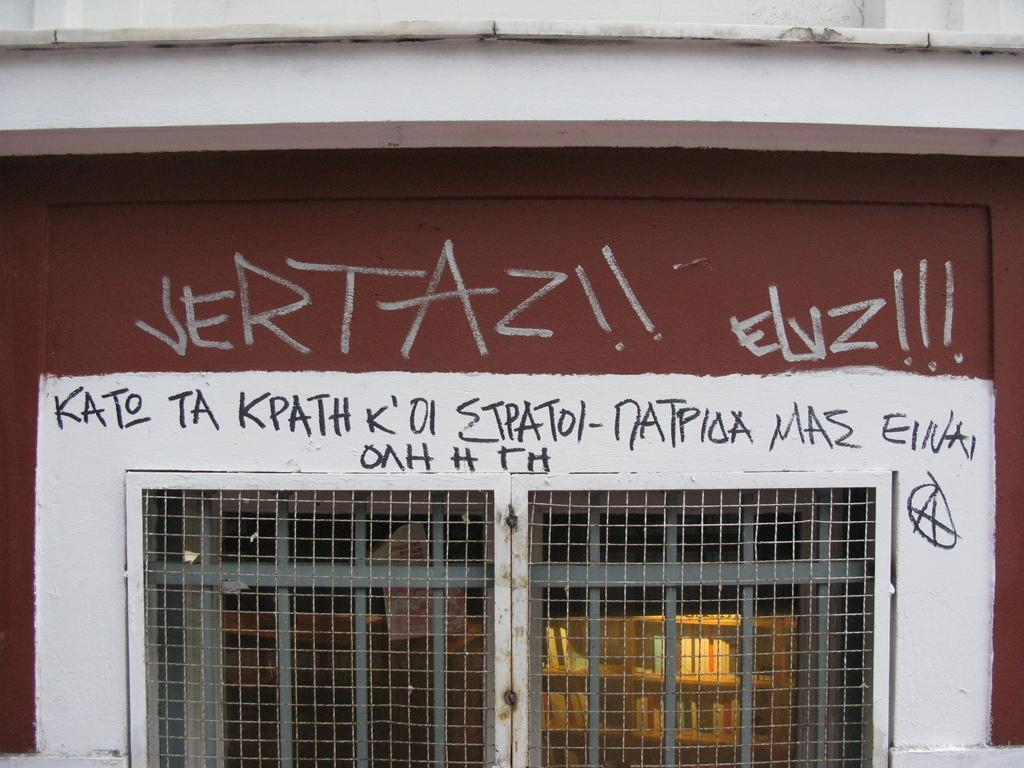What type of structure can be seen in the image? There is a wall in the image. Are there any specific features of the wall? Yes, the wall has fence doors. What type of boot is hanging on the wall in the image? There is no boot present in the image; it only features a wall with fence doors. 